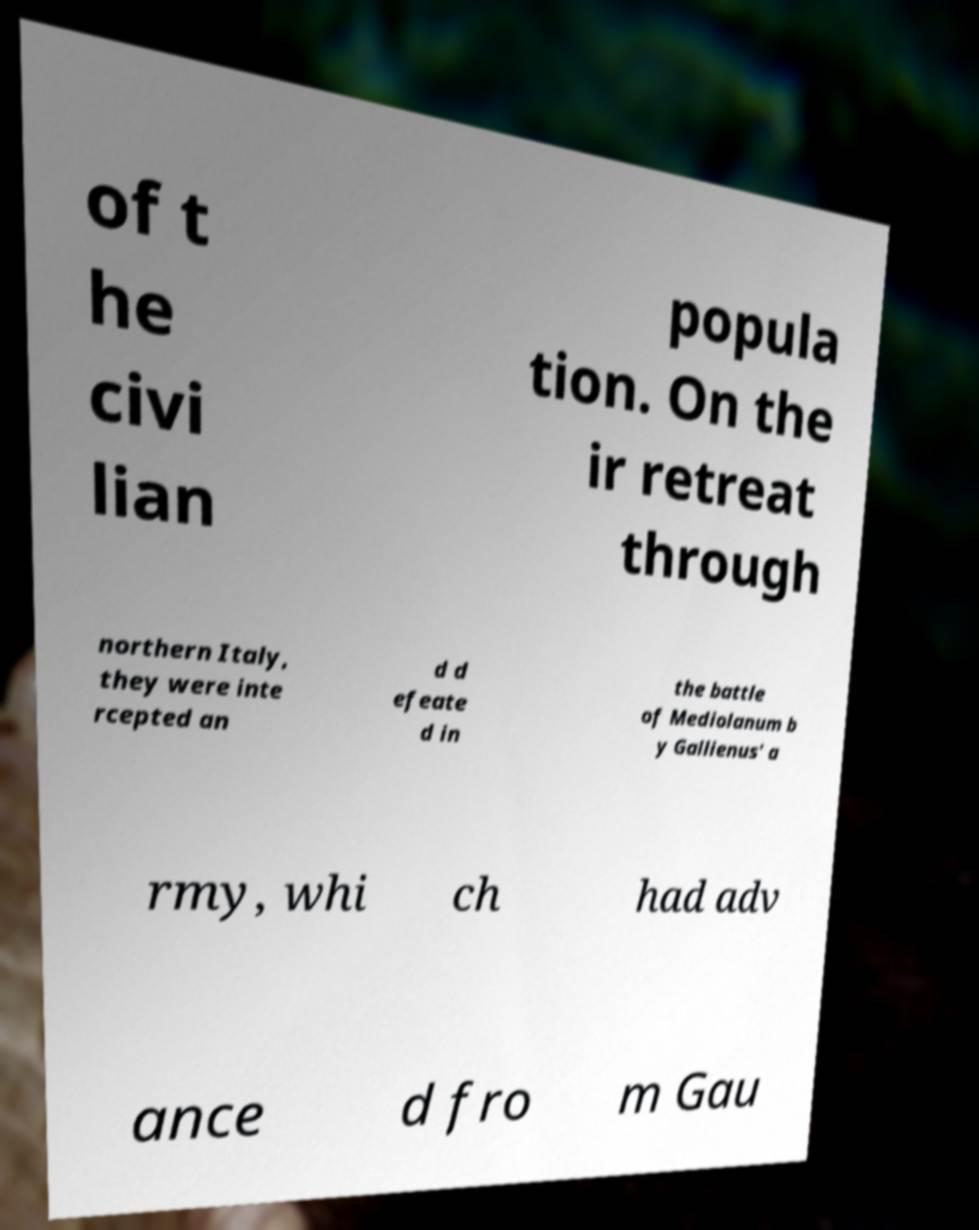There's text embedded in this image that I need extracted. Can you transcribe it verbatim? of t he civi lian popula tion. On the ir retreat through northern Italy, they were inte rcepted an d d efeate d in the battle of Mediolanum b y Gallienus' a rmy, whi ch had adv ance d fro m Gau 